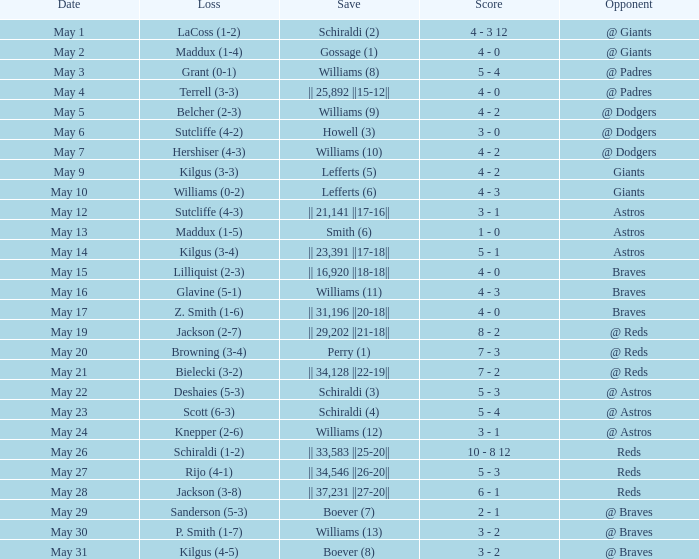Name the save for braves for may 15 || 16,920 ||18-18||. 